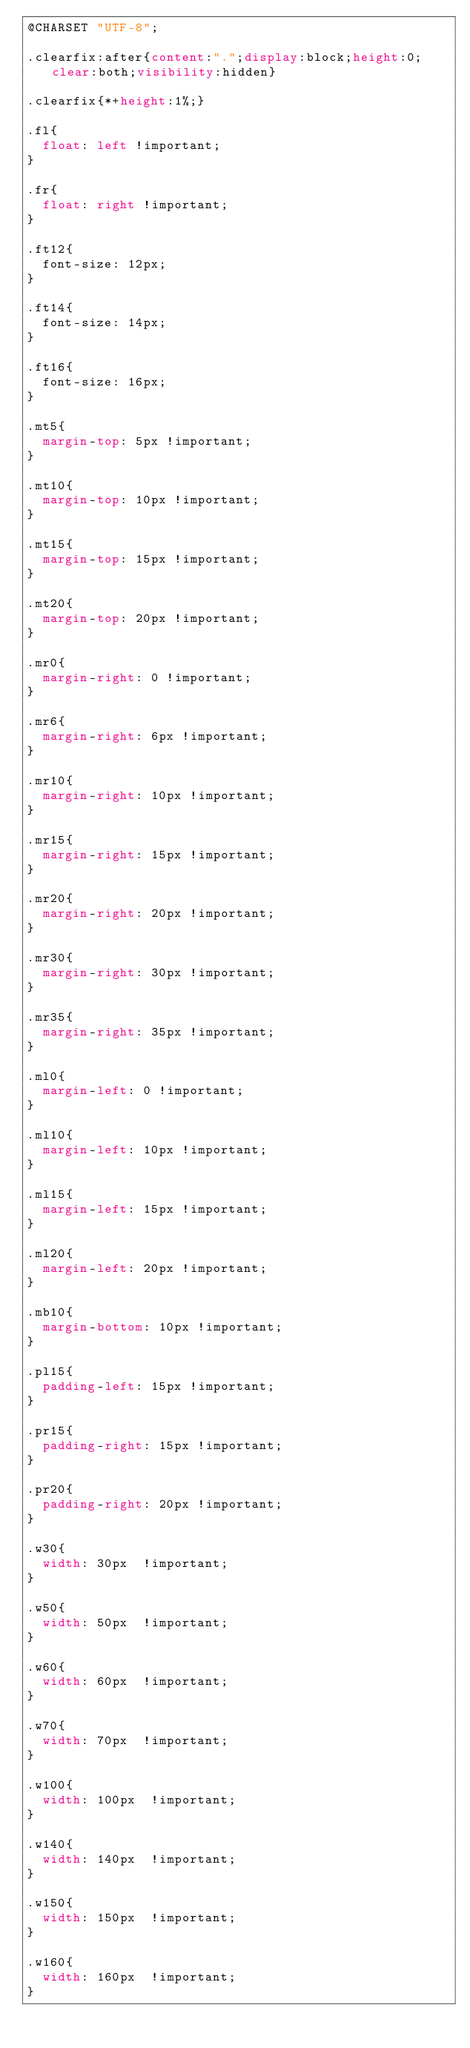Convert code to text. <code><loc_0><loc_0><loc_500><loc_500><_CSS_>@CHARSET "UTF-8";

.clearfix:after{content:".";display:block;height:0;clear:both;visibility:hidden}

.clearfix{*+height:1%;}

.fl{
	float: left !important;
}

.fr{
	float: right !important;
}

.ft12{
	font-size: 12px;
}

.ft14{
	font-size: 14px;
}

.ft16{
	font-size: 16px;	
}

.mt5{
	margin-top: 5px !important;
}

.mt10{
	margin-top: 10px !important;
}

.mt15{
	margin-top: 15px !important;
}

.mt20{
	margin-top: 20px !important;
}

.mr0{
	margin-right: 0 !important;
}

.mr6{
	margin-right: 6px !important;
}

.mr10{
	margin-right: 10px !important;
}

.mr15{
	margin-right: 15px !important;
}

.mr20{
	margin-right: 20px !important;
}

.mr30{
	margin-right: 30px !important;
}

.mr35{
	margin-right: 35px !important;
}

.ml0{
	margin-left: 0 !important;
}

.ml10{
	margin-left: 10px !important;
}

.ml15{
	margin-left: 15px !important;
}

.ml20{
	margin-left: 20px !important;
}

.mb10{
	margin-bottom: 10px !important;
}

.pl15{
	padding-left: 15px !important;
}

.pr15{
	padding-right: 15px !important;
}

.pr20{
	padding-right: 20px !important;
}

.w30{
	width: 30px  !important; 
}

.w50{
	width: 50px  !important; 
}

.w60{
	width: 60px  !important; 
}

.w70{
	width: 70px  !important; 
}

.w100{
	width: 100px  !important; 
}

.w140{
	width: 140px  !important; 
}

.w150{
	width: 150px  !important; 
}

.w160{
	width: 160px  !important; 
}
</code> 